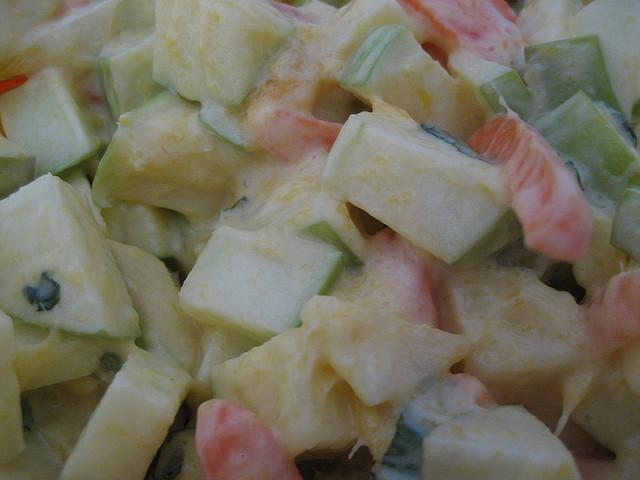Are there apples in this dish?
Write a very short answer. Yes. What is this dish?
Write a very short answer. Fruit salad. Is there melted cheese on this dish?
Keep it brief. Yes. 